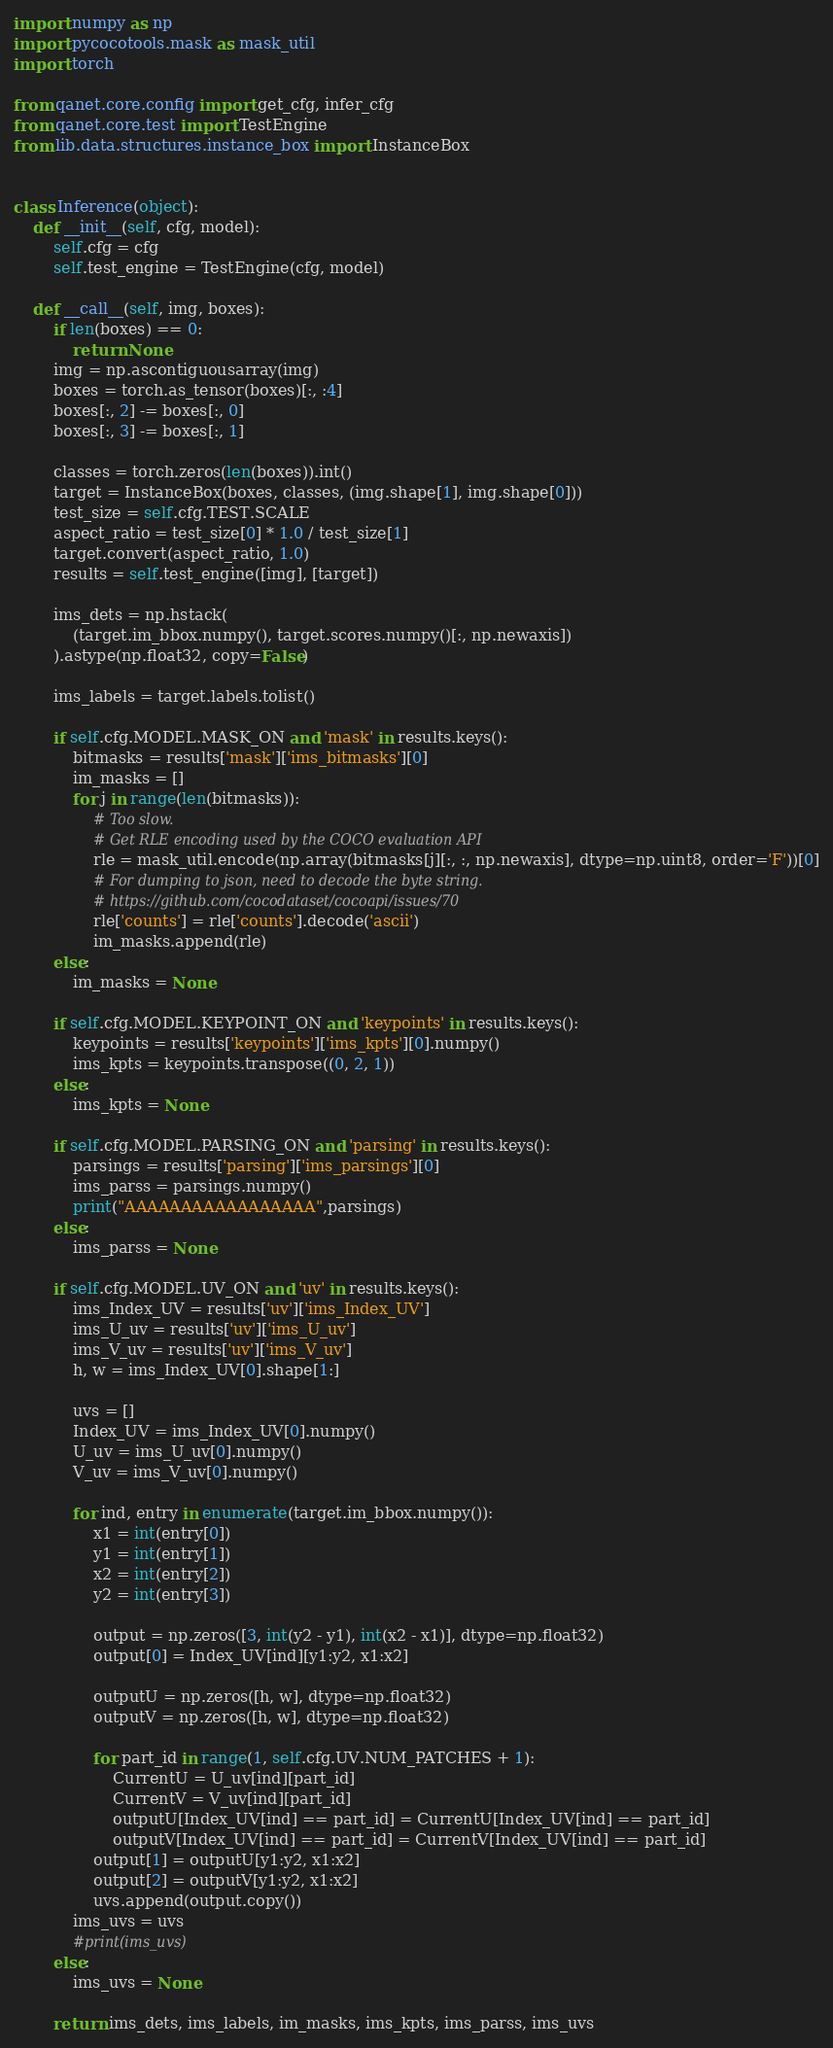<code> <loc_0><loc_0><loc_500><loc_500><_Python_>import numpy as np
import pycocotools.mask as mask_util
import torch

from qanet.core.config import get_cfg, infer_cfg
from qanet.core.test import TestEngine
from lib.data.structures.instance_box import InstanceBox


class Inference(object):
    def __init__(self, cfg, model):
        self.cfg = cfg
        self.test_engine = TestEngine(cfg, model)

    def __call__(self, img, boxes):
        if len(boxes) == 0:
            return None
        img = np.ascontiguousarray(img)
        boxes = torch.as_tensor(boxes)[:, :4]
        boxes[:, 2] -= boxes[:, 0]
        boxes[:, 3] -= boxes[:, 1]

        classes = torch.zeros(len(boxes)).int()
        target = InstanceBox(boxes, classes, (img.shape[1], img.shape[0]))
        test_size = self.cfg.TEST.SCALE
        aspect_ratio = test_size[0] * 1.0 / test_size[1]
        target.convert(aspect_ratio, 1.0)
        results = self.test_engine([img], [target])

        ims_dets = np.hstack(
            (target.im_bbox.numpy(), target.scores.numpy()[:, np.newaxis])
        ).astype(np.float32, copy=False)

        ims_labels = target.labels.tolist()

        if self.cfg.MODEL.MASK_ON and 'mask' in results.keys():
            bitmasks = results['mask']['ims_bitmasks'][0]
            im_masks = []
            for j in range(len(bitmasks)):
                # Too slow.
                # Get RLE encoding used by the COCO evaluation API
                rle = mask_util.encode(np.array(bitmasks[j][:, :, np.newaxis], dtype=np.uint8, order='F'))[0]
                # For dumping to json, need to decode the byte string.
                # https://github.com/cocodataset/cocoapi/issues/70
                rle['counts'] = rle['counts'].decode('ascii')
                im_masks.append(rle)
        else:
            im_masks = None

        if self.cfg.MODEL.KEYPOINT_ON and 'keypoints' in results.keys():
            keypoints = results['keypoints']['ims_kpts'][0].numpy()
            ims_kpts = keypoints.transpose((0, 2, 1))
        else:
            ims_kpts = None

        if self.cfg.MODEL.PARSING_ON and 'parsing' in results.keys():
            parsings = results['parsing']['ims_parsings'][0]
            ims_parss = parsings.numpy()
            print("AAAAAAAAAAAAAAAAA",parsings)
        else:
            ims_parss = None

        if self.cfg.MODEL.UV_ON and 'uv' in results.keys():
            ims_Index_UV = results['uv']['ims_Index_UV']
            ims_U_uv = results['uv']['ims_U_uv']
            ims_V_uv = results['uv']['ims_V_uv']
            h, w = ims_Index_UV[0].shape[1:]

            uvs = []
            Index_UV = ims_Index_UV[0].numpy()
            U_uv = ims_U_uv[0].numpy()
            V_uv = ims_V_uv[0].numpy()

            for ind, entry in enumerate(target.im_bbox.numpy()):
                x1 = int(entry[0])
                y1 = int(entry[1])
                x2 = int(entry[2])
                y2 = int(entry[3])

                output = np.zeros([3, int(y2 - y1), int(x2 - x1)], dtype=np.float32)
                output[0] = Index_UV[ind][y1:y2, x1:x2]

                outputU = np.zeros([h, w], dtype=np.float32)
                outputV = np.zeros([h, w], dtype=np.float32)

                for part_id in range(1, self.cfg.UV.NUM_PATCHES + 1):
                    CurrentU = U_uv[ind][part_id]
                    CurrentV = V_uv[ind][part_id]
                    outputU[Index_UV[ind] == part_id] = CurrentU[Index_UV[ind] == part_id]
                    outputV[Index_UV[ind] == part_id] = CurrentV[Index_UV[ind] == part_id]
                output[1] = outputU[y1:y2, x1:x2]
                output[2] = outputV[y1:y2, x1:x2]
                uvs.append(output.copy())
            ims_uvs = uvs
            #print(ims_uvs)
        else:
            ims_uvs = None

        return ims_dets, ims_labels, im_masks, ims_kpts, ims_parss, ims_uvs
</code> 